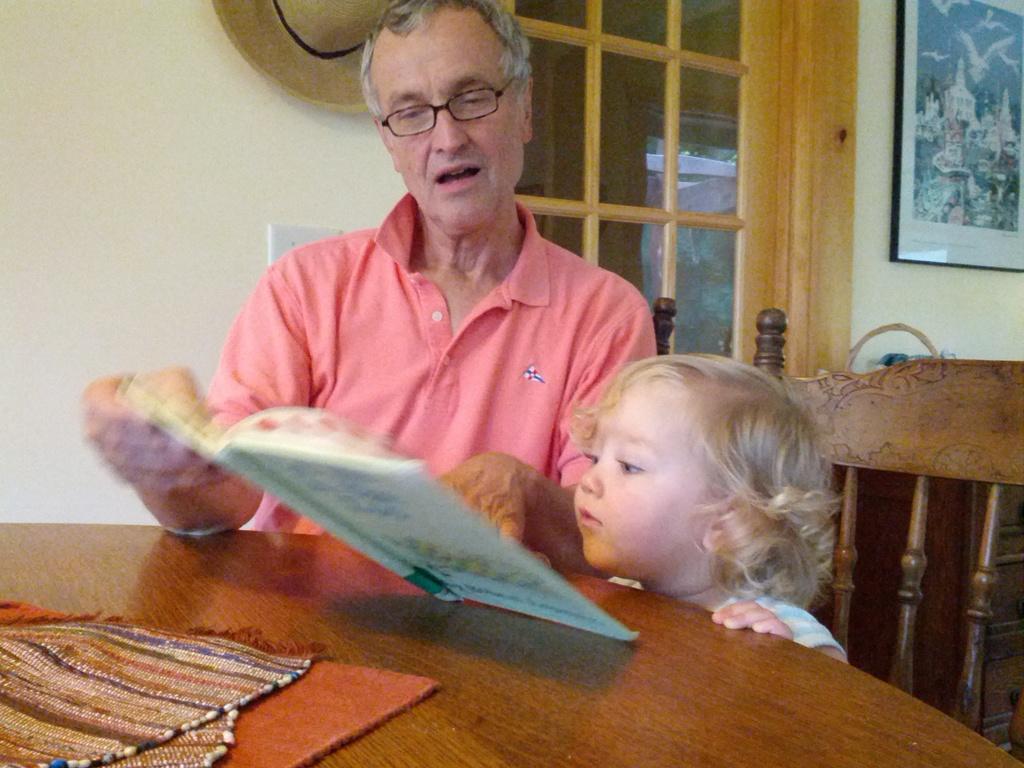Can you describe this image briefly? In this picture there is a man in the center of the image, by holding a book in his hand and there is a small girl beside him and there is a table at the bottom side of the image and there is a window, hat and a portrait in the background area of the image and there are mats on the table. 